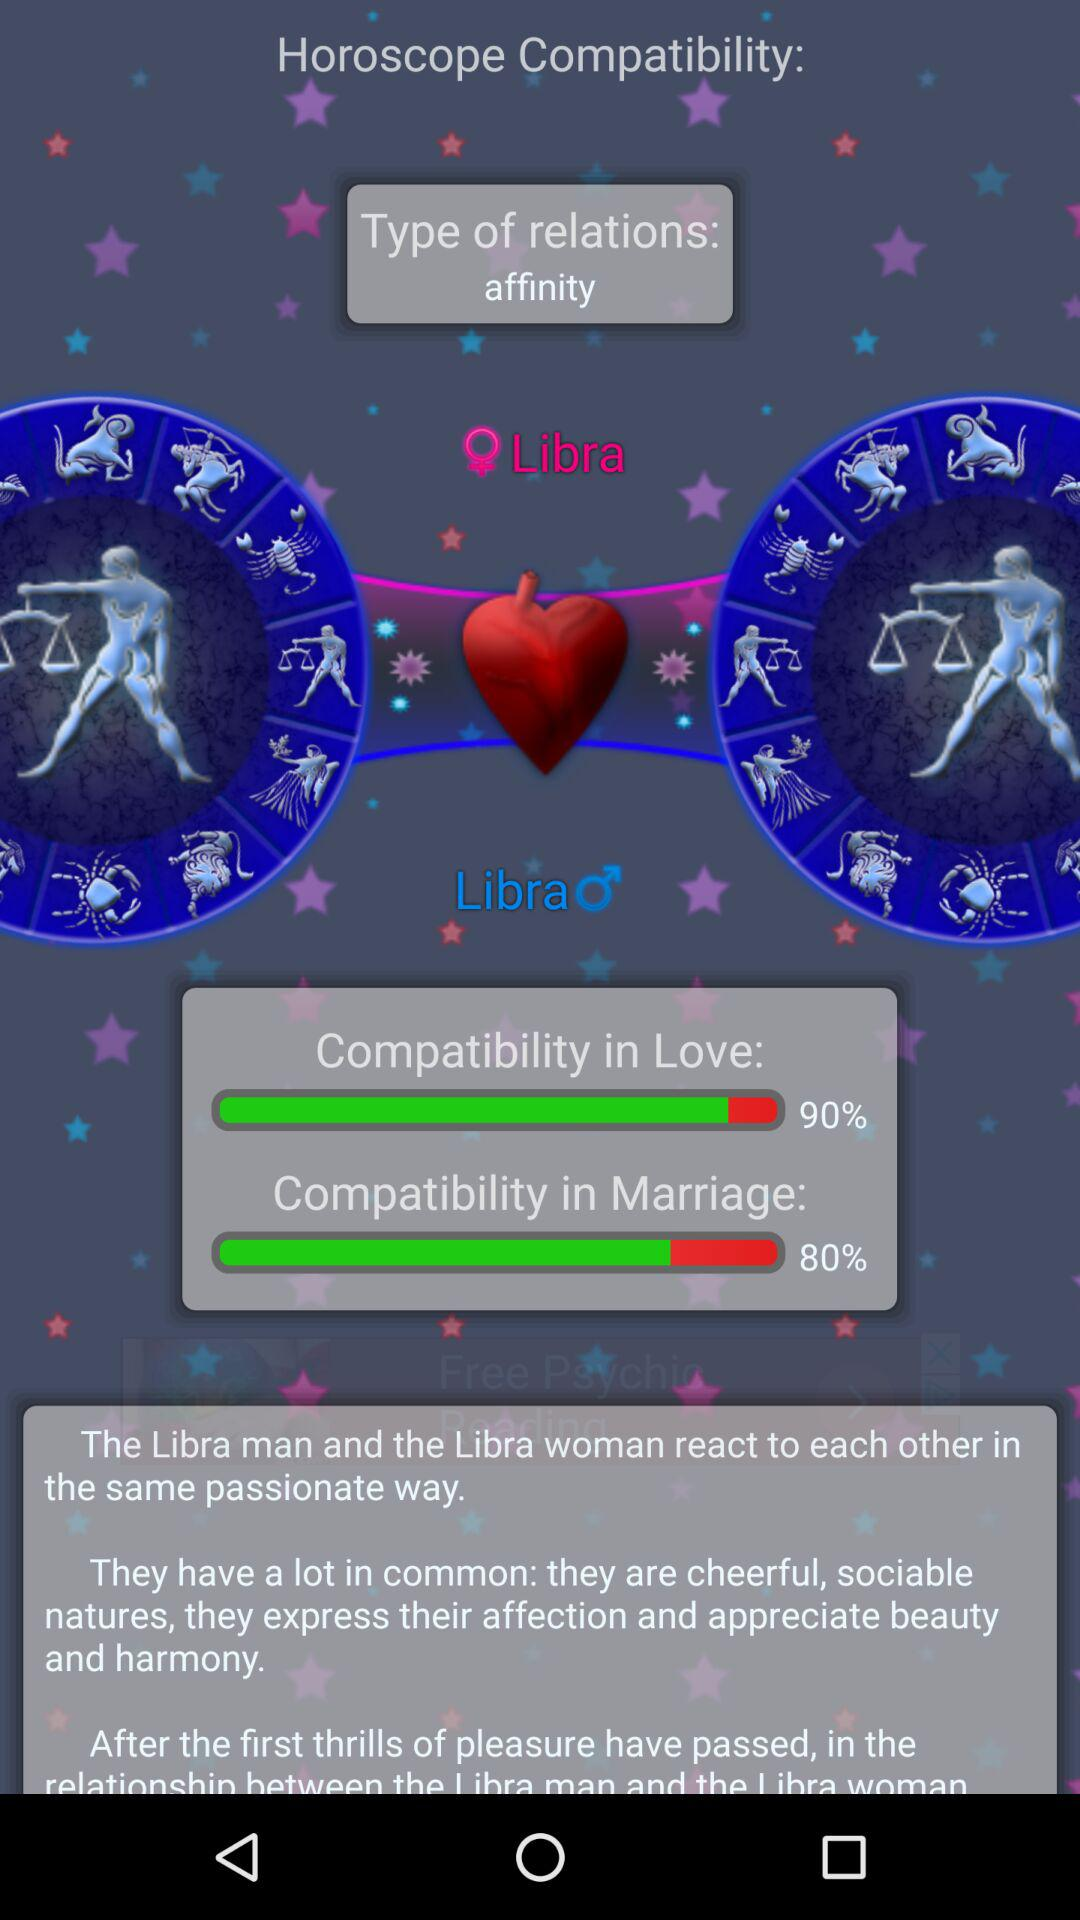What is the given relationship type? The given relationship type is "affinity". 